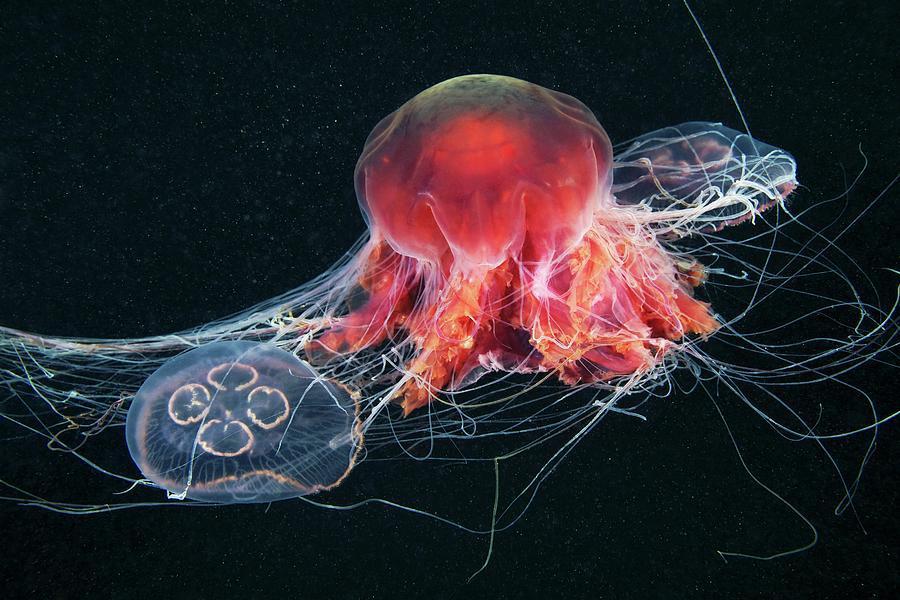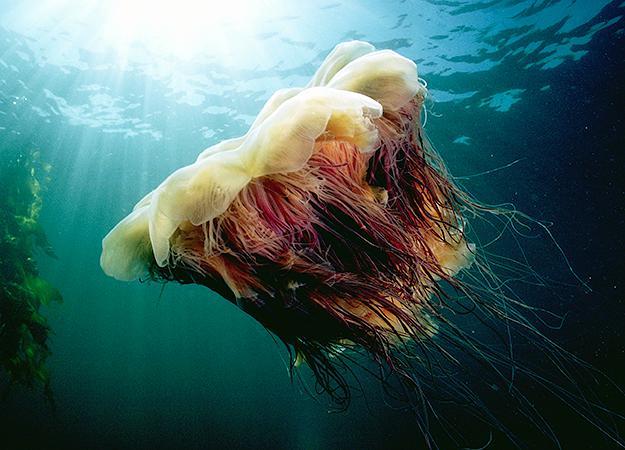The first image is the image on the left, the second image is the image on the right. Assess this claim about the two images: "An image shows a mushroom-shaped purplish jellyfish with tentacles reaching in all directions and enveloping at least one other creature.". Correct or not? Answer yes or no. Yes. 